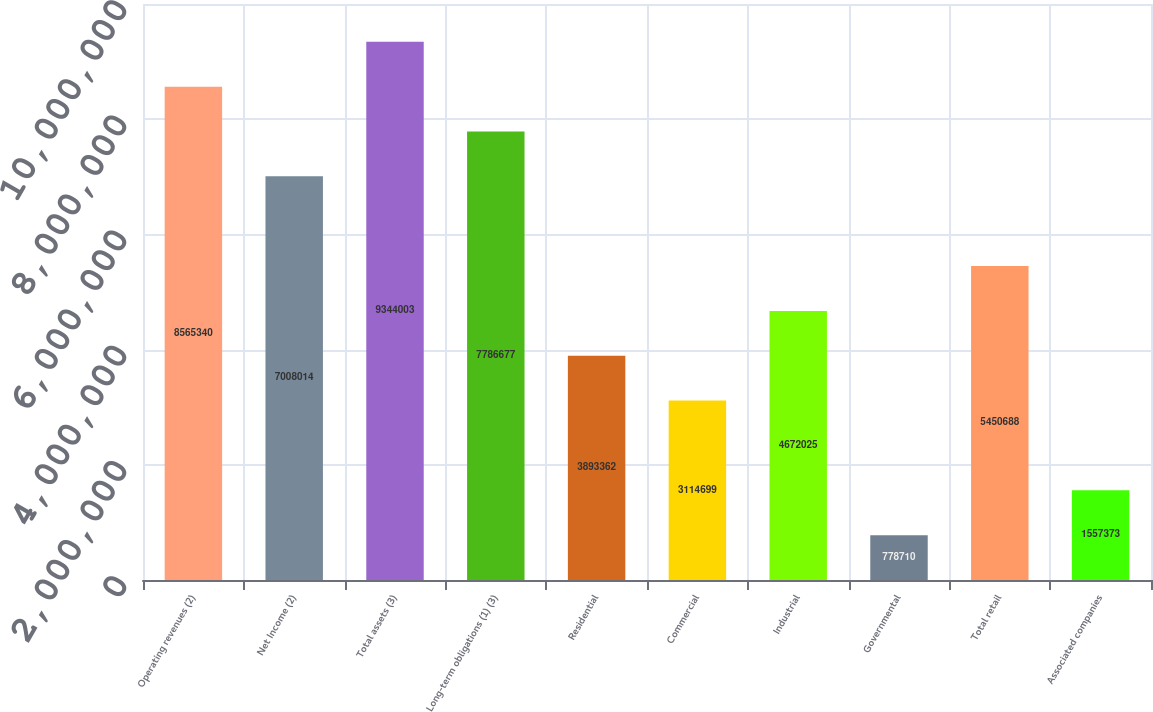Convert chart to OTSL. <chart><loc_0><loc_0><loc_500><loc_500><bar_chart><fcel>Operating revenues (2)<fcel>Net Income (2)<fcel>Total assets (3)<fcel>Long-term obligations (1) (3)<fcel>Residential<fcel>Commercial<fcel>Industrial<fcel>Governmental<fcel>Total retail<fcel>Associated companies<nl><fcel>8.56534e+06<fcel>7.00801e+06<fcel>9.344e+06<fcel>7.78668e+06<fcel>3.89336e+06<fcel>3.1147e+06<fcel>4.67202e+06<fcel>778710<fcel>5.45069e+06<fcel>1.55737e+06<nl></chart> 